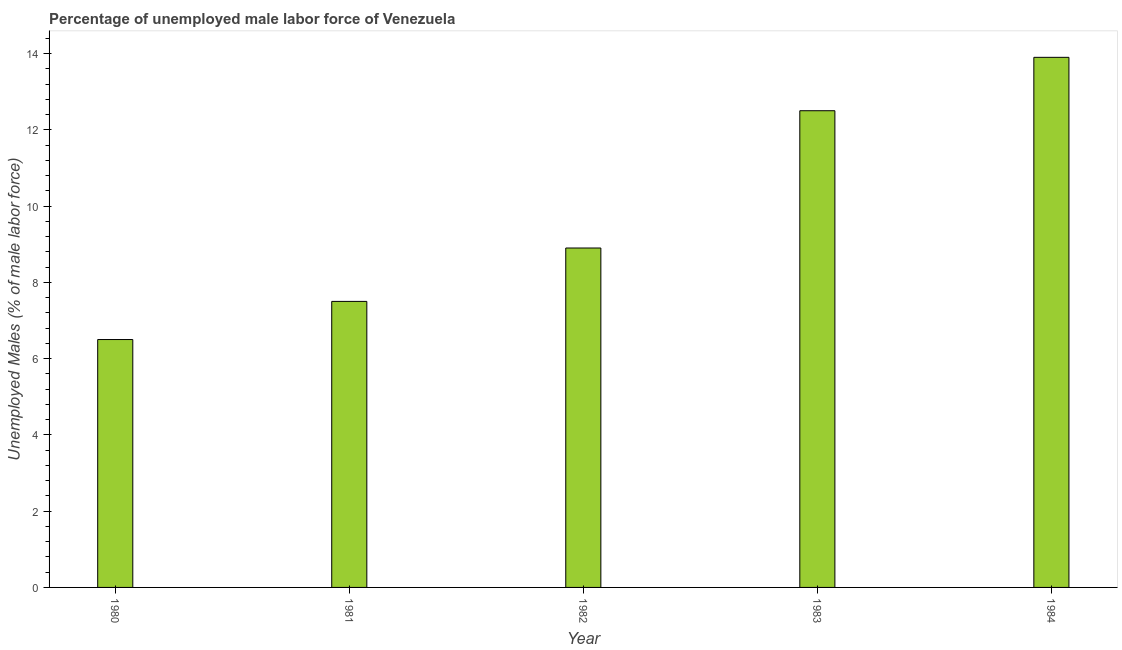Does the graph contain any zero values?
Give a very brief answer. No. Does the graph contain grids?
Your response must be concise. No. What is the title of the graph?
Your answer should be compact. Percentage of unemployed male labor force of Venezuela. What is the label or title of the Y-axis?
Your answer should be compact. Unemployed Males (% of male labor force). What is the total unemployed male labour force in 1984?
Keep it short and to the point. 13.9. Across all years, what is the maximum total unemployed male labour force?
Your answer should be very brief. 13.9. In which year was the total unemployed male labour force maximum?
Ensure brevity in your answer.  1984. In which year was the total unemployed male labour force minimum?
Your answer should be compact. 1980. What is the sum of the total unemployed male labour force?
Keep it short and to the point. 49.3. What is the average total unemployed male labour force per year?
Offer a terse response. 9.86. What is the median total unemployed male labour force?
Make the answer very short. 8.9. Do a majority of the years between 1982 and 1983 (inclusive) have total unemployed male labour force greater than 8.8 %?
Your response must be concise. Yes. What is the ratio of the total unemployed male labour force in 1980 to that in 1984?
Offer a very short reply. 0.47. Is the difference between the total unemployed male labour force in 1982 and 1984 greater than the difference between any two years?
Your answer should be very brief. No. What is the difference between the highest and the lowest total unemployed male labour force?
Your answer should be compact. 7.4. In how many years, is the total unemployed male labour force greater than the average total unemployed male labour force taken over all years?
Keep it short and to the point. 2. What is the difference between two consecutive major ticks on the Y-axis?
Your response must be concise. 2. What is the Unemployed Males (% of male labor force) of 1982?
Your answer should be compact. 8.9. What is the Unemployed Males (% of male labor force) in 1984?
Make the answer very short. 13.9. What is the difference between the Unemployed Males (% of male labor force) in 1980 and 1981?
Give a very brief answer. -1. What is the difference between the Unemployed Males (% of male labor force) in 1980 and 1982?
Offer a very short reply. -2.4. What is the difference between the Unemployed Males (% of male labor force) in 1980 and 1984?
Ensure brevity in your answer.  -7.4. What is the difference between the Unemployed Males (% of male labor force) in 1982 and 1984?
Your answer should be compact. -5. What is the ratio of the Unemployed Males (% of male labor force) in 1980 to that in 1981?
Your answer should be compact. 0.87. What is the ratio of the Unemployed Males (% of male labor force) in 1980 to that in 1982?
Your answer should be compact. 0.73. What is the ratio of the Unemployed Males (% of male labor force) in 1980 to that in 1983?
Keep it short and to the point. 0.52. What is the ratio of the Unemployed Males (% of male labor force) in 1980 to that in 1984?
Ensure brevity in your answer.  0.47. What is the ratio of the Unemployed Males (% of male labor force) in 1981 to that in 1982?
Give a very brief answer. 0.84. What is the ratio of the Unemployed Males (% of male labor force) in 1981 to that in 1984?
Give a very brief answer. 0.54. What is the ratio of the Unemployed Males (% of male labor force) in 1982 to that in 1983?
Make the answer very short. 0.71. What is the ratio of the Unemployed Males (% of male labor force) in 1982 to that in 1984?
Give a very brief answer. 0.64. What is the ratio of the Unemployed Males (% of male labor force) in 1983 to that in 1984?
Keep it short and to the point. 0.9. 